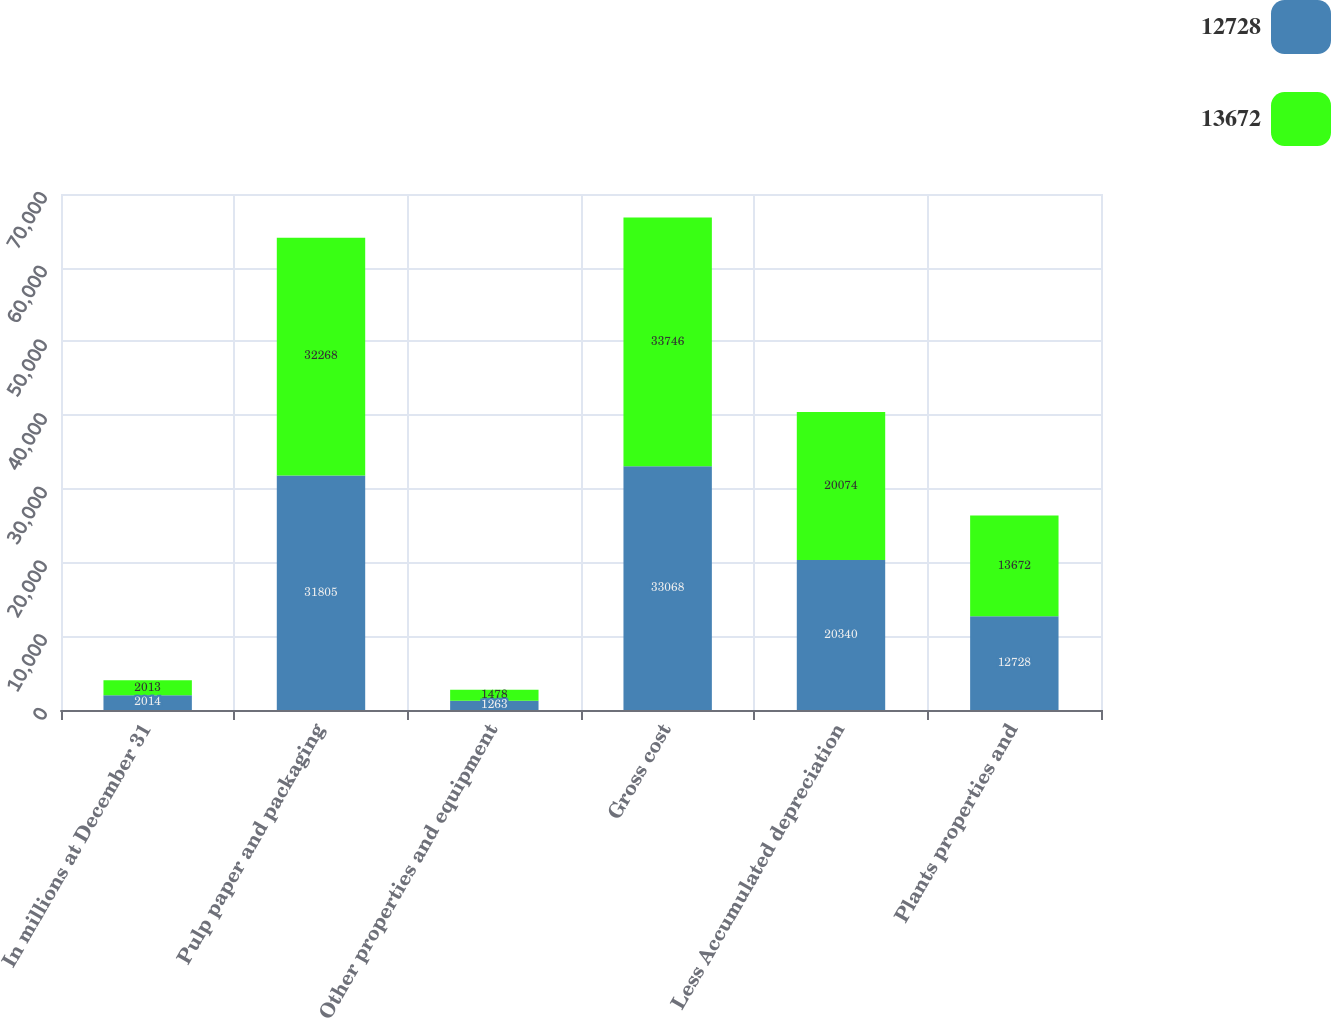Convert chart. <chart><loc_0><loc_0><loc_500><loc_500><stacked_bar_chart><ecel><fcel>In millions at December 31<fcel>Pulp paper and packaging<fcel>Other properties and equipment<fcel>Gross cost<fcel>Less Accumulated depreciation<fcel>Plants properties and<nl><fcel>12728<fcel>2014<fcel>31805<fcel>1263<fcel>33068<fcel>20340<fcel>12728<nl><fcel>13672<fcel>2013<fcel>32268<fcel>1478<fcel>33746<fcel>20074<fcel>13672<nl></chart> 